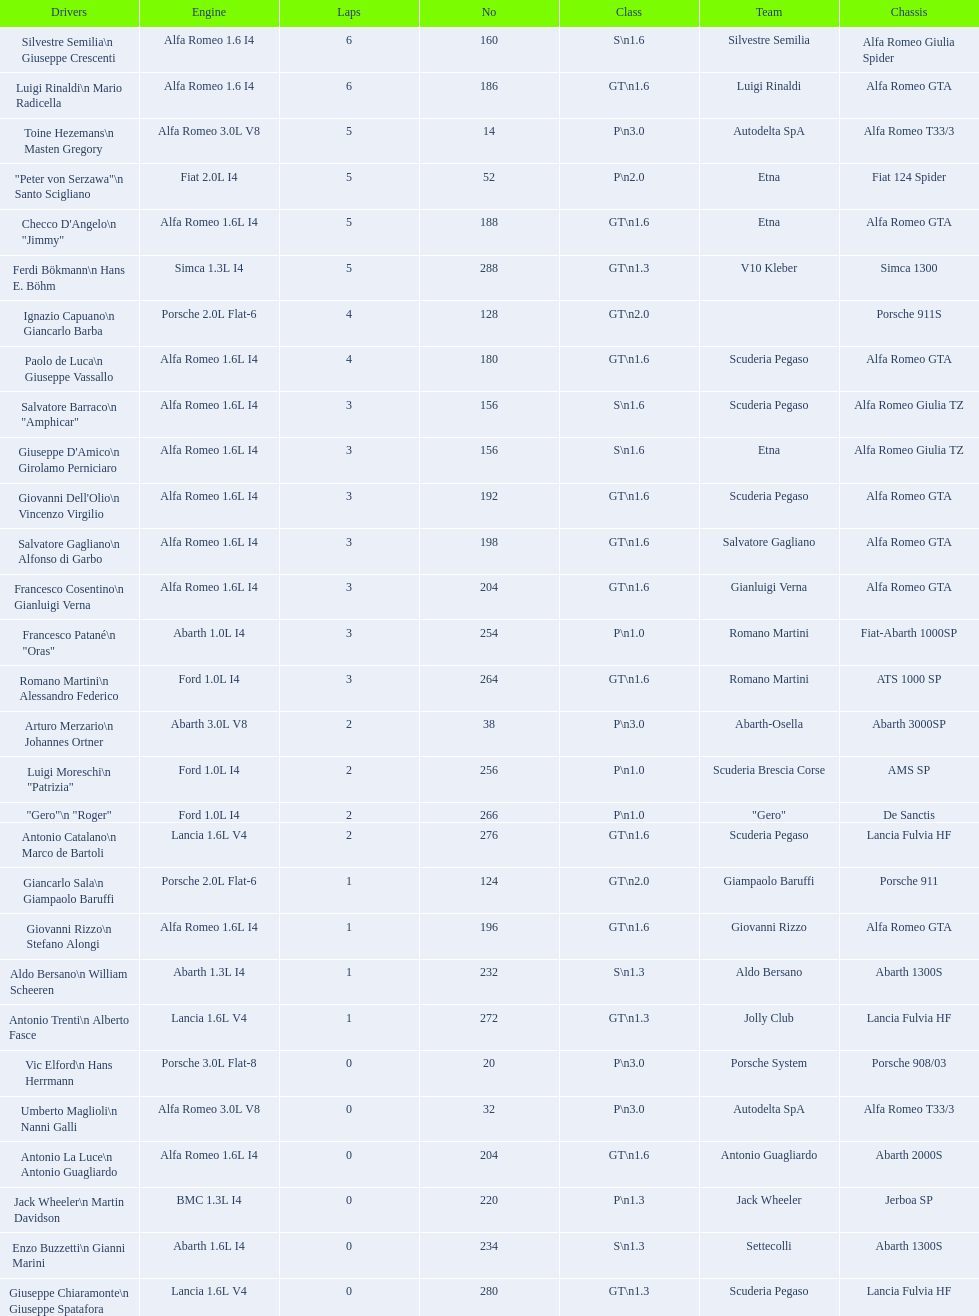Name the only american who did not finish the race. Masten Gregory. 